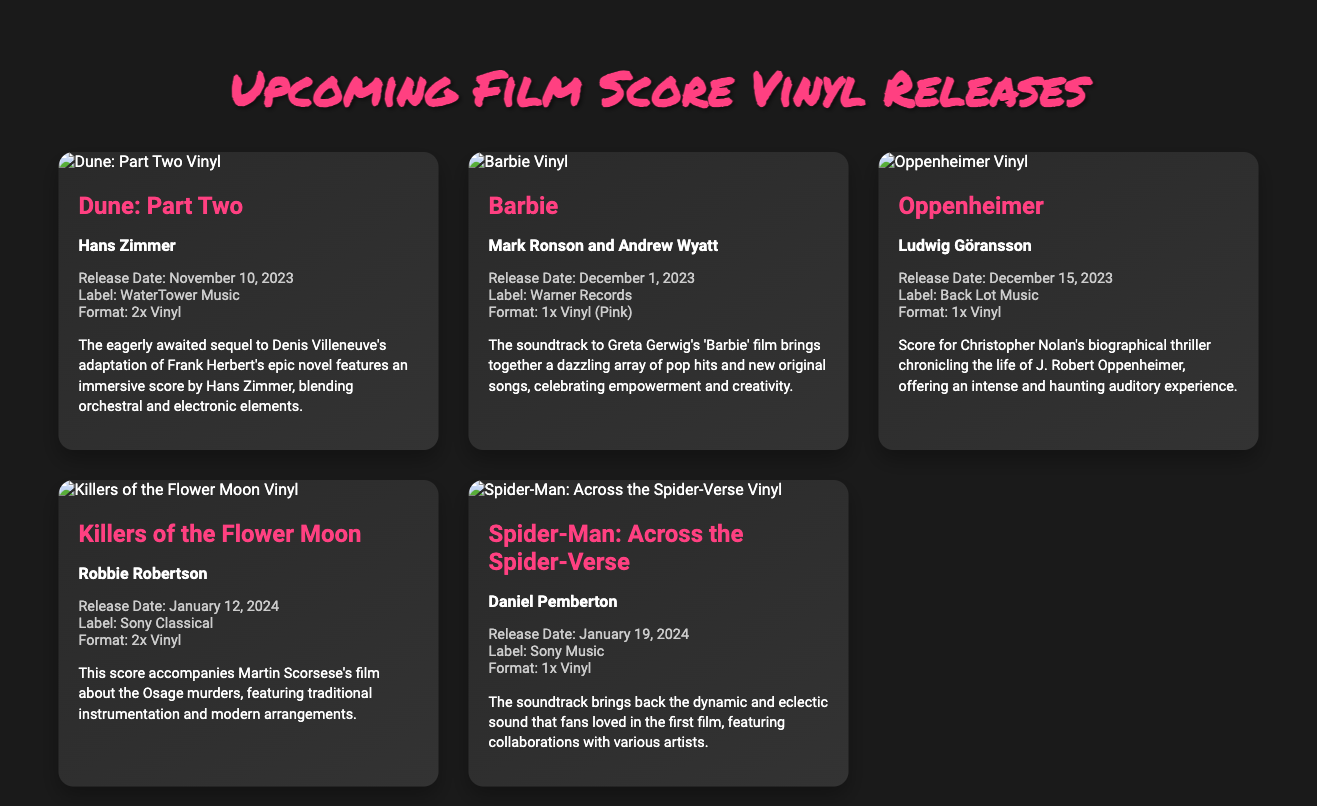What is the release date for Dune: Part Two? The release date for Dune: Part Two is stated in the document as November 10, 2023.
Answer: November 10, 2023 Who is the composer of the Oppenheimer soundtrack? The document lists Ludwig Göransson as the composer of the Oppenheimer soundtrack.
Answer: Ludwig Göransson What format will the Killers of the Flower Moon soundtrack be released in? The document specifies that the Killers of the Flower Moon soundtrack will be released as 2x Vinyl.
Answer: 2x Vinyl Which film's soundtrack is described as having a "dazzling array of pop hits"? The description of the Barbie soundtrack mentions it brings together a "dazzling array of pop hits."
Answer: Barbie What label is releasing the Spider-Man: Across the Spider-Verse soundtrack? According to the document, the Spider-Man: Across the Spider-Verse soundtrack will be released by Sony Music.
Answer: Sony Music Which soundtrack has a release date the earliest in 2024? The Killers of the Flower Moon soundtrack has a release date of January 12, 2024, which is the earliest in 2024.
Answer: Killers of the Flower Moon How many vinyl records will the Oppenheimer soundtrack consist of? The release details for Oppenheimer indicate it will be released on 1x Vinyl.
Answer: 1x Vinyl What is the main theme of the Dune: Part Two score described in the document? The Dune: Part Two score features an "immersive score" blending orchestral and electronic elements.
Answer: Immersive score blending orchestral and electronic elements What is the promotional color of the Barbie vinyl release? The document states that the Barbie vinyl release is in Pink.
Answer: Pink 